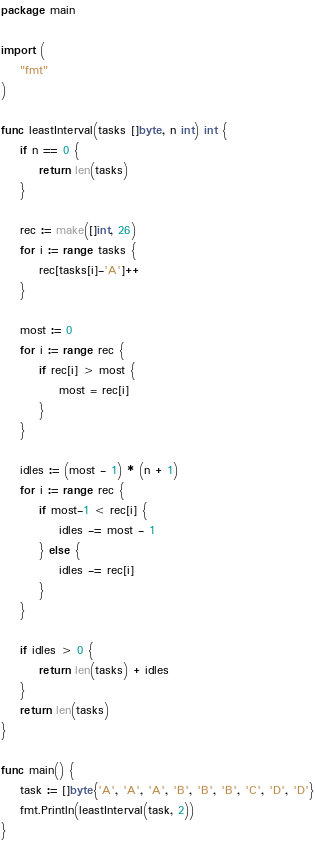<code> <loc_0><loc_0><loc_500><loc_500><_Go_>package main

import (
	"fmt"
)

func leastInterval(tasks []byte, n int) int {
	if n == 0 {
		return len(tasks)
	}

	rec := make([]int, 26)
	for i := range tasks {
		rec[tasks[i]-'A']++
	}

	most := 0
	for i := range rec {
		if rec[i] > most {
			most = rec[i]
		}
	}

	idles := (most - 1) * (n + 1)
	for i := range rec {
		if most-1 < rec[i] {
			idles -= most - 1
		} else {
			idles -= rec[i]
		}
	}

	if idles > 0 {
		return len(tasks) + idles
	}
	return len(tasks)
}

func main() {
	task := []byte{'A', 'A', 'A', 'B', 'B', 'B', 'C', 'D', 'D'}
	fmt.Println(leastInterval(task, 2))
}
</code> 